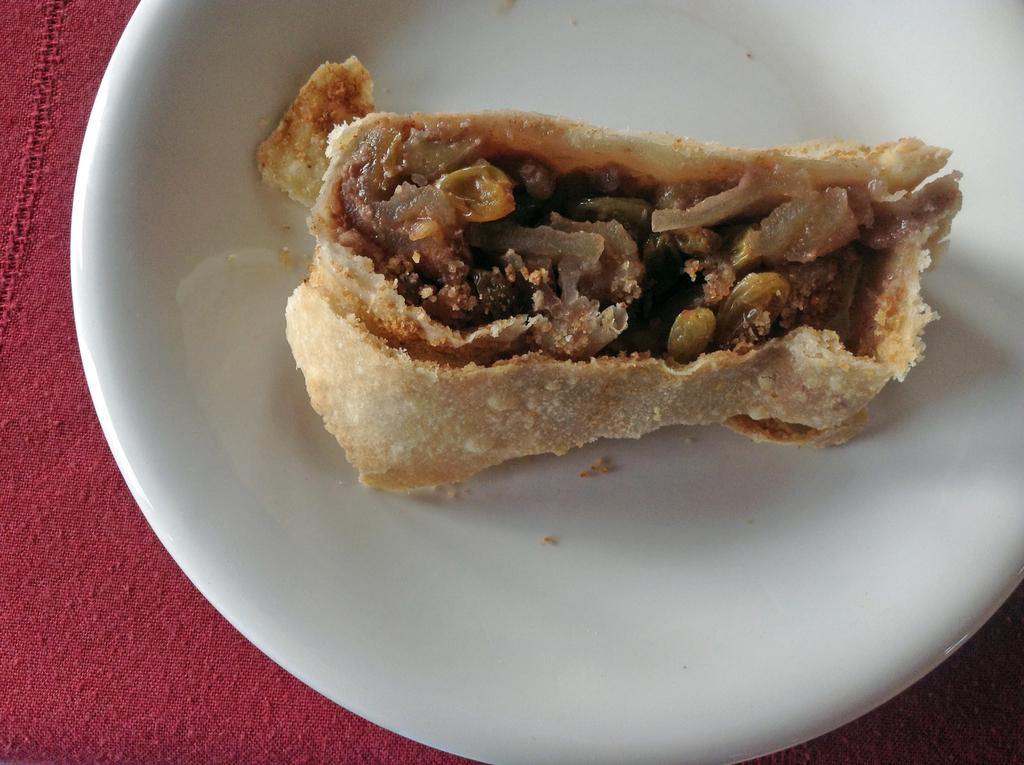What is placed on the plate in the image? There is a food product placed on a plate in the image. What color is the plate? The plate is white. What is the color of the cloth surface beneath the plate? The cloth surface beneath the plate is red. What type of porter is shown carrying a cast in the image? There is no porter or cast present in the image; it only features a food product on a plate. 